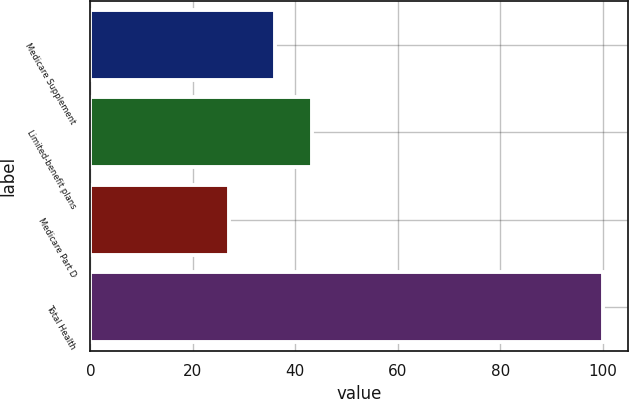Convert chart. <chart><loc_0><loc_0><loc_500><loc_500><bar_chart><fcel>Medicare Supplement<fcel>Limited-benefit plans<fcel>Medicare Part D<fcel>Total Health<nl><fcel>36<fcel>43.3<fcel>27<fcel>100<nl></chart> 